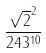<formula> <loc_0><loc_0><loc_500><loc_500>\frac { \sqrt { 2 } ^ { 2 } } { 2 4 3 ^ { 1 0 } }</formula> 